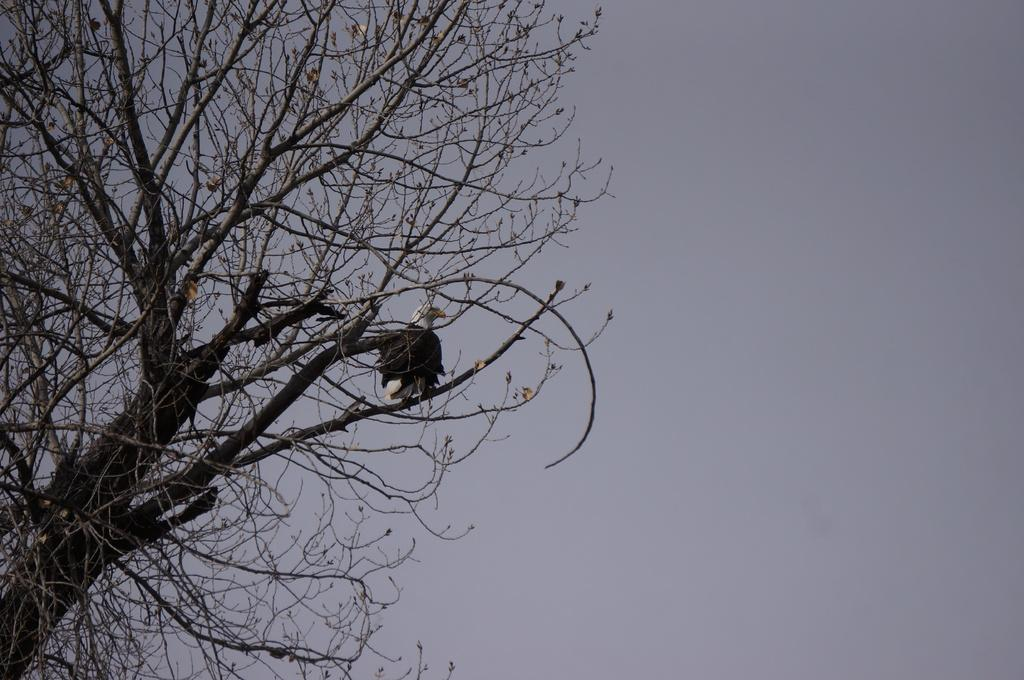What animal can be seen in the image? There is an eagle in the image. Where is the eagle sitting? The eagle is sitting on a dry tree. What colors are present on the eagle? The eagle has brown and white coloring. What can be seen in the background of the image? The sky is visible in the image. What is the color of the sky in the image? The sky is white in color. Can you see the arch that the eagle is using to perform magic in the image? There is no arch or magic present in the image; it features an eagle sitting on a dry tree with a white sky in the background. 